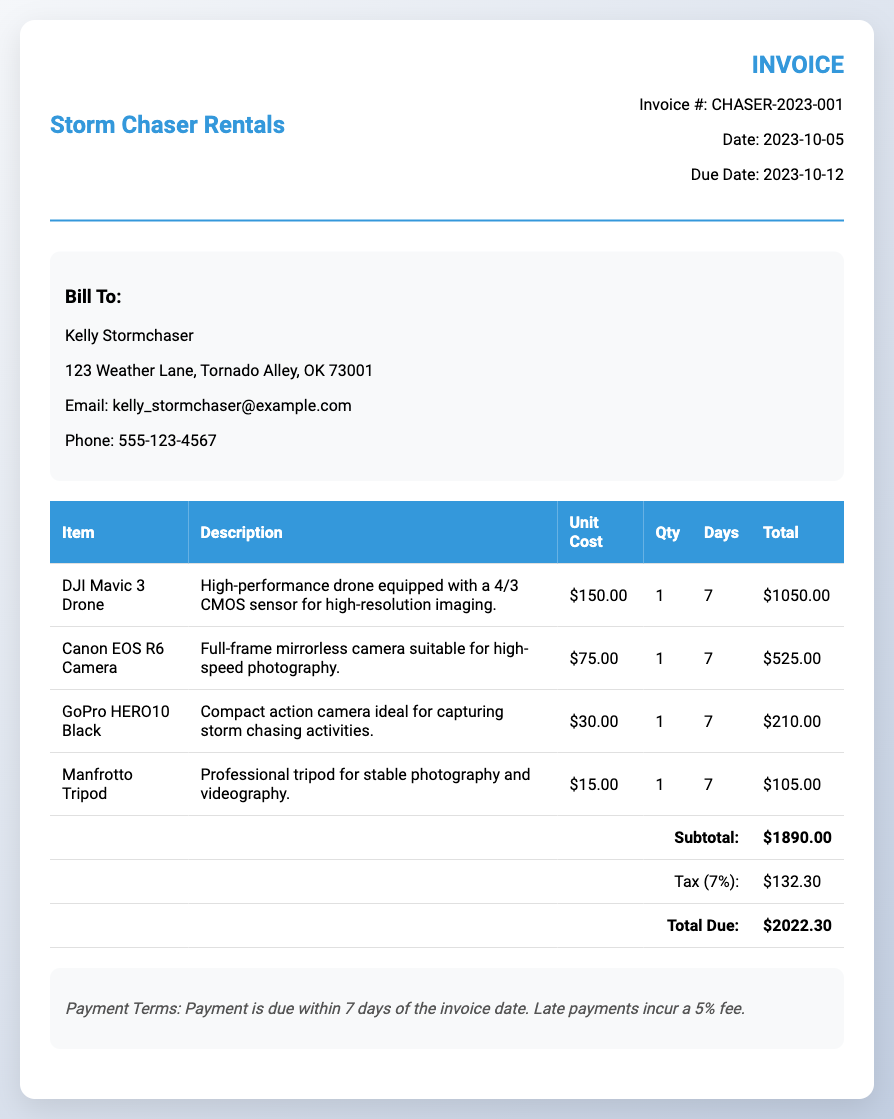What is the invoice number? The invoice number is listed in the header section of the document.
Answer: CHASER-2023-001 What is the due date for payment? The due date is mentioned in the invoice details.
Answer: 2023-10-12 How many days was the DJI Mavic 3 Drone rented? The rental duration for the DJI Mavic 3 Drone is specified in the table.
Answer: 7 What is the unit cost of the Canon EOS R6 Camera? The unit cost is listed in the table under the 'Unit Cost' column for the Canon EOS R6 Camera.
Answer: $75.00 What is the subtotal amount? The subtotal is calculated and shown near the bottom of the table as the sum of all item totals.
Answer: $1890.00 What is the total amount due including tax? The total due is calculated as the subtotal plus tax and is shown at the bottom of the table.
Answer: $2022.30 Who is the invoice billed to? The client details section of the document indicates the name of the person billed.
Answer: Kelly Stormchaser What is the tax percentage applied to the subtotal? The tax percentage is mentioned next to the tax amount in the document.
Answer: 7% What is the payment term stated in the document? The payment terms are outlined in a specified section of the invoice.
Answer: Payment is due within 7 days of the invoice date. Late payments incur a 5% fee 